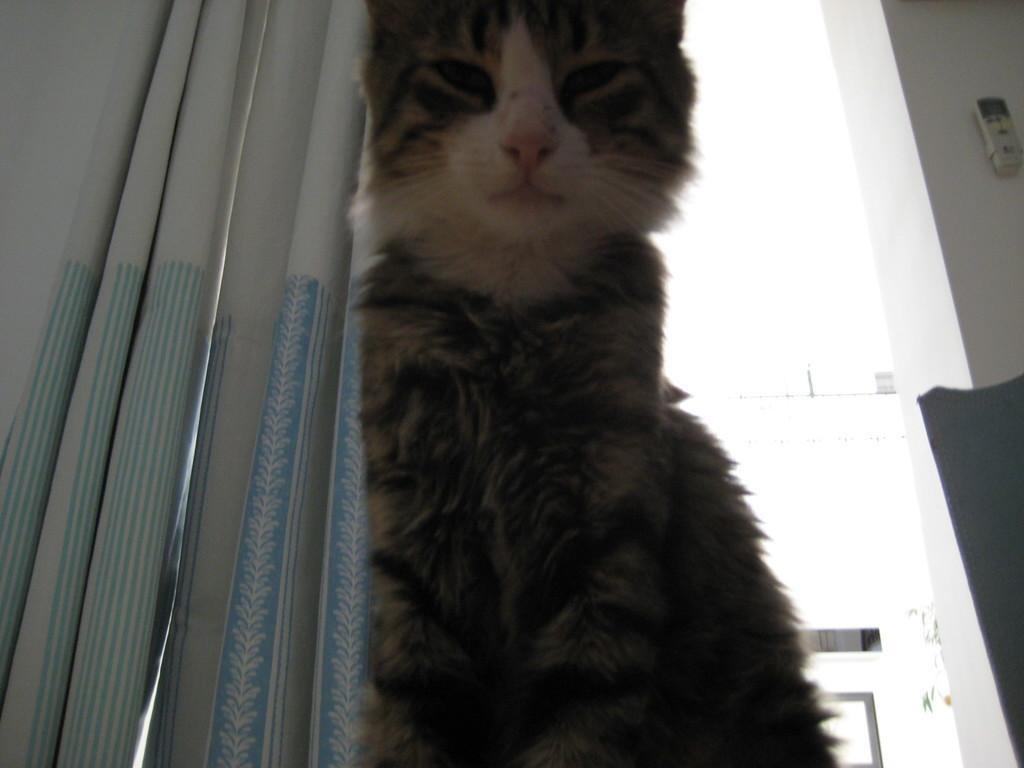Please provide a concise description of this image. In the picture we can see a cat sitting near the window, the cat is gray, black and some part white in color near its mouth and nose and behind the cat we can see a curtain which is white in color with some blue color lines on it with some designs and beside it we can see a wall and something placed in it. 